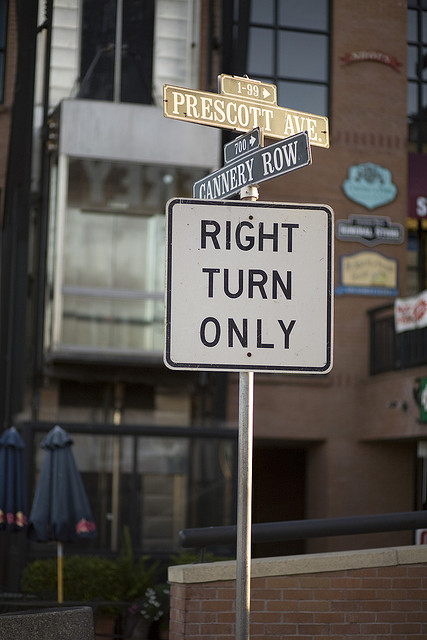<image>Was this taken in a place of business? It's ambiguous whether the image was taken in a place of business. What city is this? I don't know which city this is. It may be Prescott, New York, England, Atlanta, Prescott Ave, Chicago or Monterrey. Was this taken in a place of business? I am not sure if this was taken in a place of business. It can be both in a place of business or not. What city is this? We don't know what city this is. It can be any of 'prescott', 'new york', 'atlanta', 'prescott ave', 'chicago', or 'monterrey'. 